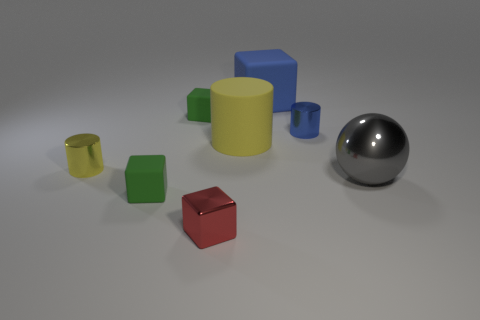Is there any other thing that has the same shape as the gray object?
Offer a terse response. No. There is a large yellow cylinder left of the large ball; how many matte cubes are to the right of it?
Ensure brevity in your answer.  1. Is the shape of the small green rubber object in front of the blue metal cylinder the same as the tiny metal thing in front of the tiny yellow metal thing?
Keep it short and to the point. Yes. What is the size of the cylinder that is in front of the blue metal thing and to the right of the small yellow cylinder?
Provide a short and direct response. Large. There is a large object that is the same shape as the tiny red metal thing; what is its color?
Give a very brief answer. Blue. There is a tiny object that is left of the tiny matte cube that is in front of the tiny blue metallic thing; what is its color?
Make the answer very short. Yellow. The tiny blue object is what shape?
Provide a succinct answer. Cylinder. What shape is the tiny metallic object that is both behind the metal block and on the right side of the yellow metallic thing?
Provide a succinct answer. Cylinder. What is the color of the tiny block that is made of the same material as the large sphere?
Ensure brevity in your answer.  Red. What is the shape of the small green thing that is behind the green matte object to the left of the tiny matte block that is behind the tiny yellow metal cylinder?
Your answer should be compact. Cube. 